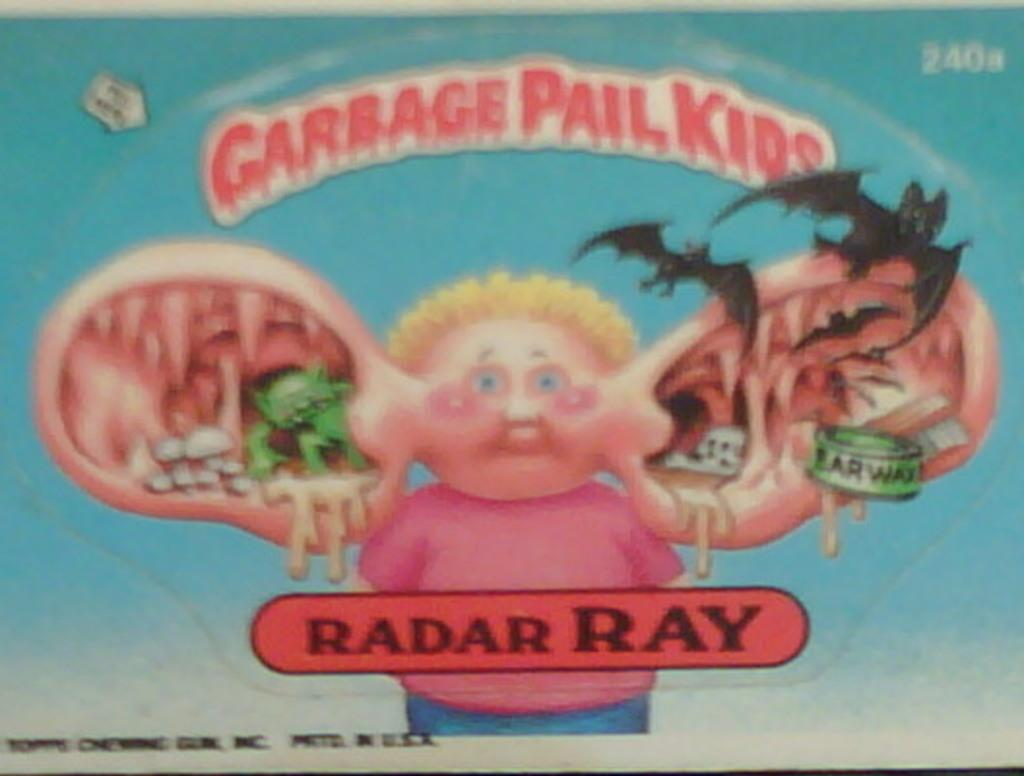<image>
Give a short and clear explanation of the subsequent image. Poster showing a boy with large ears and the words "Radar Ray" under him. 